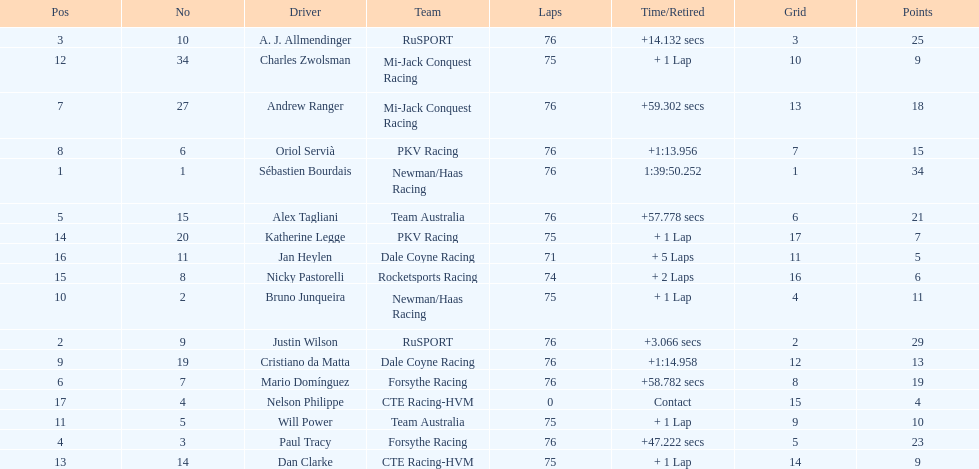Charles zwolsman acquired the same number of points as who? Dan Clarke. 